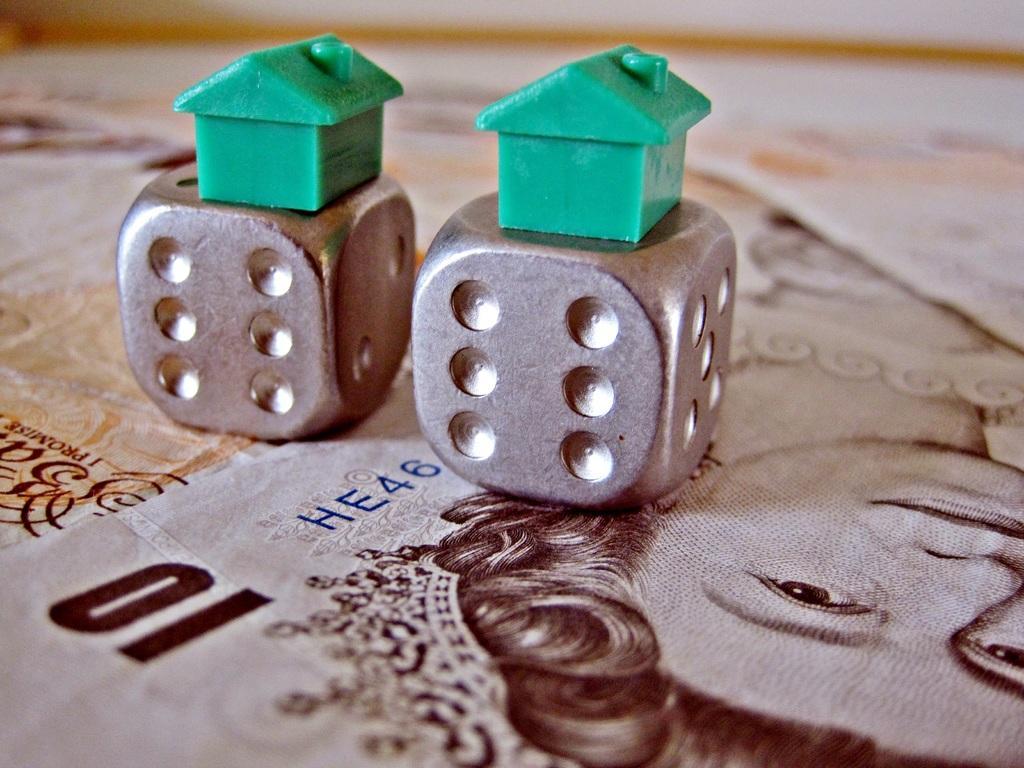In one or two sentences, can you explain what this image depicts? In this image in the center there are two dice, and at the bottom there might be papers. On the papers there is text and an image of a person and some objects, and there is blurry background. 